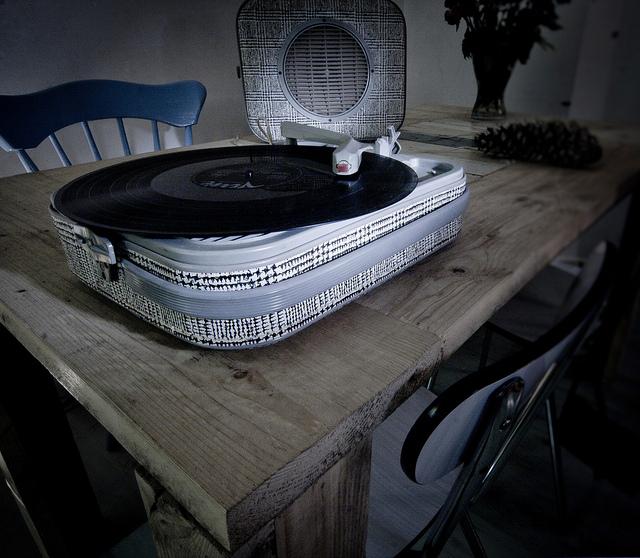What is silver colored on the chair?
Quick response, please. Paint. Is there a toilet in this picture?
Short answer required. No. What is the table top made out of?
Keep it brief. Wood. What is the white and blue object made of?
Keep it brief. Wood. Is this a bathroom?
Write a very short answer. No. Is there a vase?
Give a very brief answer. Yes. What style record player is this?
Keep it brief. Vintage. 